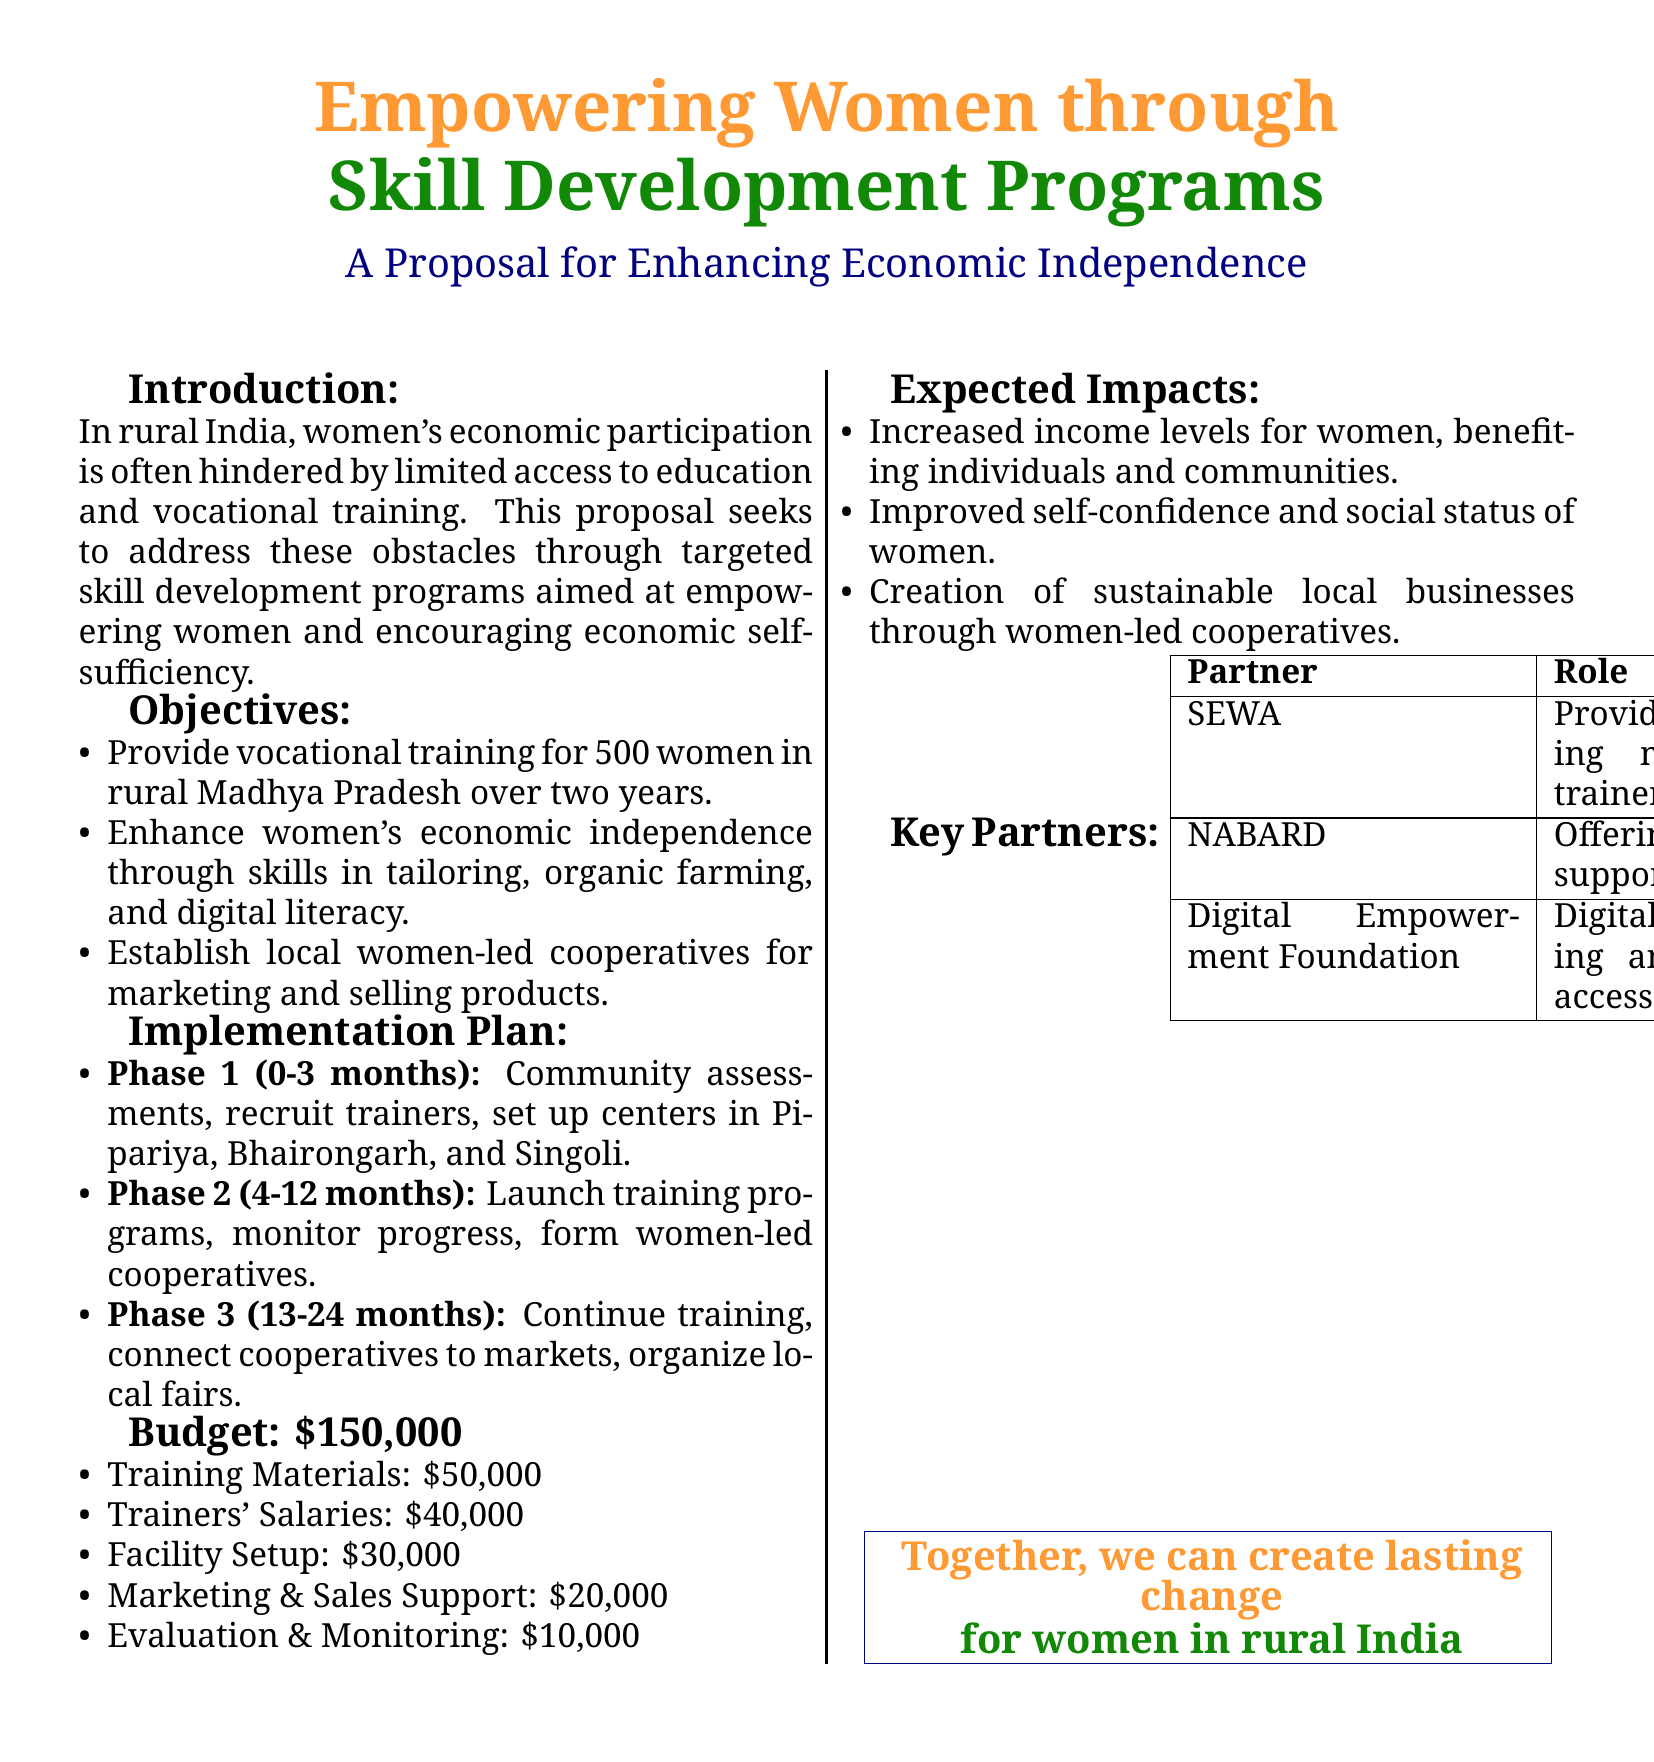What is the total budget for the project? The total budget is explicitly listed in the document, indicating the total amount allocated for the project.
Answer: $150,000 How many women will receive vocational training? The document specifies the target number of women who will participate in the vocational training programs.
Answer: 500 What skills will the training programs focus on? The proposal outlines the specific skills that the training programs aim to develop among the women participants.
Answer: Tailoring, organic farming, and digital literacy What is the duration of the project? The implementation plan includes a timeline for the project, indicating its duration.
Answer: 24 months Who is the partner responsible for providing training materials? The document lists key partners and their roles, including one that specifically provides training materials.
Answer: SEWA In which rural areas will the training centers be set up? The document identifies the specific locations where the training centers will be established.
Answer: Pipariya, Bhairongarh, and Singoli What is the primary objective of the proposal? The document states the main goal of the project regarding women empowerment and economic independence.
Answer: Empowering women and encouraging economic self-sufficiency What type of cooperatives will be established? The proposal mentions the kind of cooperatives that will be formed as part of the women's training initiative.
Answer: Women-led cooperatives What will be the expected impact on women's self-confidence? The expected impacts section discusses changes that will result from the project.
Answer: Improved self-confidence and social status of women 